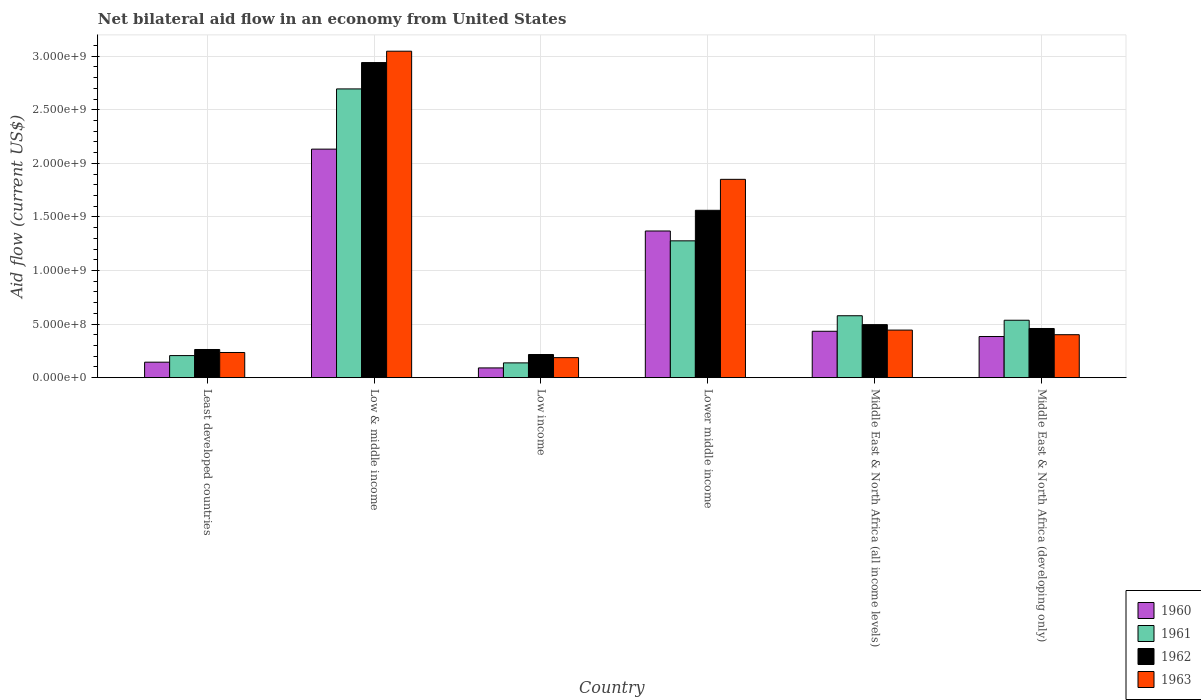How many bars are there on the 3rd tick from the left?
Your answer should be very brief. 4. How many bars are there on the 4th tick from the right?
Offer a very short reply. 4. What is the label of the 2nd group of bars from the left?
Your response must be concise. Low & middle income. In how many cases, is the number of bars for a given country not equal to the number of legend labels?
Offer a very short reply. 0. What is the net bilateral aid flow in 1960 in Lower middle income?
Your answer should be compact. 1.37e+09. Across all countries, what is the maximum net bilateral aid flow in 1962?
Your response must be concise. 2.94e+09. Across all countries, what is the minimum net bilateral aid flow in 1962?
Offer a very short reply. 2.16e+08. What is the total net bilateral aid flow in 1963 in the graph?
Offer a terse response. 6.16e+09. What is the difference between the net bilateral aid flow in 1963 in Least developed countries and that in Middle East & North Africa (developing only)?
Give a very brief answer. -1.66e+08. What is the difference between the net bilateral aid flow in 1962 in Lower middle income and the net bilateral aid flow in 1960 in Least developed countries?
Keep it short and to the point. 1.42e+09. What is the average net bilateral aid flow in 1960 per country?
Keep it short and to the point. 7.59e+08. What is the difference between the net bilateral aid flow of/in 1960 and net bilateral aid flow of/in 1963 in Middle East & North Africa (all income levels)?
Provide a short and direct response. -1.10e+07. What is the ratio of the net bilateral aid flow in 1961 in Lower middle income to that in Middle East & North Africa (all income levels)?
Ensure brevity in your answer.  2.21. Is the difference between the net bilateral aid flow in 1960 in Low income and Middle East & North Africa (developing only) greater than the difference between the net bilateral aid flow in 1963 in Low income and Middle East & North Africa (developing only)?
Provide a succinct answer. No. What is the difference between the highest and the second highest net bilateral aid flow in 1963?
Give a very brief answer. 2.60e+09. What is the difference between the highest and the lowest net bilateral aid flow in 1963?
Provide a succinct answer. 2.86e+09. In how many countries, is the net bilateral aid flow in 1961 greater than the average net bilateral aid flow in 1961 taken over all countries?
Make the answer very short. 2. Is the sum of the net bilateral aid flow in 1961 in Low & middle income and Low income greater than the maximum net bilateral aid flow in 1963 across all countries?
Give a very brief answer. No. Is it the case that in every country, the sum of the net bilateral aid flow in 1962 and net bilateral aid flow in 1960 is greater than the sum of net bilateral aid flow in 1963 and net bilateral aid flow in 1961?
Make the answer very short. No. What does the 2nd bar from the left in Middle East & North Africa (developing only) represents?
Ensure brevity in your answer.  1961. How many bars are there?
Your response must be concise. 24. Are the values on the major ticks of Y-axis written in scientific E-notation?
Keep it short and to the point. Yes. How many legend labels are there?
Provide a succinct answer. 4. How are the legend labels stacked?
Offer a very short reply. Vertical. What is the title of the graph?
Your answer should be very brief. Net bilateral aid flow in an economy from United States. What is the label or title of the X-axis?
Offer a very short reply. Country. What is the Aid flow (current US$) of 1960 in Least developed countries?
Ensure brevity in your answer.  1.45e+08. What is the Aid flow (current US$) in 1961 in Least developed countries?
Ensure brevity in your answer.  2.06e+08. What is the Aid flow (current US$) of 1962 in Least developed countries?
Provide a succinct answer. 2.63e+08. What is the Aid flow (current US$) in 1963 in Least developed countries?
Offer a terse response. 2.35e+08. What is the Aid flow (current US$) in 1960 in Low & middle income?
Make the answer very short. 2.13e+09. What is the Aid flow (current US$) of 1961 in Low & middle income?
Give a very brief answer. 2.70e+09. What is the Aid flow (current US$) in 1962 in Low & middle income?
Provide a succinct answer. 2.94e+09. What is the Aid flow (current US$) of 1963 in Low & middle income?
Provide a short and direct response. 3.05e+09. What is the Aid flow (current US$) in 1960 in Low income?
Make the answer very short. 9.10e+07. What is the Aid flow (current US$) in 1961 in Low income?
Give a very brief answer. 1.38e+08. What is the Aid flow (current US$) of 1962 in Low income?
Your answer should be very brief. 2.16e+08. What is the Aid flow (current US$) of 1963 in Low income?
Provide a succinct answer. 1.87e+08. What is the Aid flow (current US$) in 1960 in Lower middle income?
Provide a short and direct response. 1.37e+09. What is the Aid flow (current US$) of 1961 in Lower middle income?
Your answer should be compact. 1.28e+09. What is the Aid flow (current US$) of 1962 in Lower middle income?
Give a very brief answer. 1.56e+09. What is the Aid flow (current US$) in 1963 in Lower middle income?
Keep it short and to the point. 1.85e+09. What is the Aid flow (current US$) in 1960 in Middle East & North Africa (all income levels)?
Keep it short and to the point. 4.33e+08. What is the Aid flow (current US$) in 1961 in Middle East & North Africa (all income levels)?
Your response must be concise. 5.78e+08. What is the Aid flow (current US$) of 1962 in Middle East & North Africa (all income levels)?
Ensure brevity in your answer.  4.95e+08. What is the Aid flow (current US$) in 1963 in Middle East & North Africa (all income levels)?
Offer a very short reply. 4.44e+08. What is the Aid flow (current US$) of 1960 in Middle East & North Africa (developing only)?
Keep it short and to the point. 3.84e+08. What is the Aid flow (current US$) in 1961 in Middle East & North Africa (developing only)?
Provide a succinct answer. 5.36e+08. What is the Aid flow (current US$) in 1962 in Middle East & North Africa (developing only)?
Offer a terse response. 4.59e+08. What is the Aid flow (current US$) in 1963 in Middle East & North Africa (developing only)?
Provide a short and direct response. 4.01e+08. Across all countries, what is the maximum Aid flow (current US$) of 1960?
Keep it short and to the point. 2.13e+09. Across all countries, what is the maximum Aid flow (current US$) of 1961?
Give a very brief answer. 2.70e+09. Across all countries, what is the maximum Aid flow (current US$) in 1962?
Give a very brief answer. 2.94e+09. Across all countries, what is the maximum Aid flow (current US$) of 1963?
Make the answer very short. 3.05e+09. Across all countries, what is the minimum Aid flow (current US$) in 1960?
Give a very brief answer. 9.10e+07. Across all countries, what is the minimum Aid flow (current US$) of 1961?
Ensure brevity in your answer.  1.38e+08. Across all countries, what is the minimum Aid flow (current US$) of 1962?
Your answer should be very brief. 2.16e+08. Across all countries, what is the minimum Aid flow (current US$) of 1963?
Give a very brief answer. 1.87e+08. What is the total Aid flow (current US$) of 1960 in the graph?
Your response must be concise. 4.55e+09. What is the total Aid flow (current US$) in 1961 in the graph?
Offer a very short reply. 5.43e+09. What is the total Aid flow (current US$) of 1962 in the graph?
Provide a short and direct response. 5.94e+09. What is the total Aid flow (current US$) in 1963 in the graph?
Provide a short and direct response. 6.16e+09. What is the difference between the Aid flow (current US$) of 1960 in Least developed countries and that in Low & middle income?
Give a very brief answer. -1.99e+09. What is the difference between the Aid flow (current US$) of 1961 in Least developed countries and that in Low & middle income?
Keep it short and to the point. -2.49e+09. What is the difference between the Aid flow (current US$) of 1962 in Least developed countries and that in Low & middle income?
Offer a terse response. -2.68e+09. What is the difference between the Aid flow (current US$) in 1963 in Least developed countries and that in Low & middle income?
Your answer should be compact. -2.81e+09. What is the difference between the Aid flow (current US$) of 1960 in Least developed countries and that in Low income?
Offer a very short reply. 5.35e+07. What is the difference between the Aid flow (current US$) in 1961 in Least developed countries and that in Low income?
Provide a short and direct response. 6.80e+07. What is the difference between the Aid flow (current US$) of 1962 in Least developed countries and that in Low income?
Ensure brevity in your answer.  4.70e+07. What is the difference between the Aid flow (current US$) of 1963 in Least developed countries and that in Low income?
Provide a succinct answer. 4.80e+07. What is the difference between the Aid flow (current US$) in 1960 in Least developed countries and that in Lower middle income?
Your answer should be very brief. -1.22e+09. What is the difference between the Aid flow (current US$) of 1961 in Least developed countries and that in Lower middle income?
Make the answer very short. -1.07e+09. What is the difference between the Aid flow (current US$) of 1962 in Least developed countries and that in Lower middle income?
Give a very brief answer. -1.30e+09. What is the difference between the Aid flow (current US$) of 1963 in Least developed countries and that in Lower middle income?
Offer a very short reply. -1.62e+09. What is the difference between the Aid flow (current US$) in 1960 in Least developed countries and that in Middle East & North Africa (all income levels)?
Provide a short and direct response. -2.88e+08. What is the difference between the Aid flow (current US$) of 1961 in Least developed countries and that in Middle East & North Africa (all income levels)?
Ensure brevity in your answer.  -3.72e+08. What is the difference between the Aid flow (current US$) of 1962 in Least developed countries and that in Middle East & North Africa (all income levels)?
Your answer should be very brief. -2.32e+08. What is the difference between the Aid flow (current US$) in 1963 in Least developed countries and that in Middle East & North Africa (all income levels)?
Make the answer very short. -2.09e+08. What is the difference between the Aid flow (current US$) of 1960 in Least developed countries and that in Middle East & North Africa (developing only)?
Ensure brevity in your answer.  -2.39e+08. What is the difference between the Aid flow (current US$) of 1961 in Least developed countries and that in Middle East & North Africa (developing only)?
Give a very brief answer. -3.30e+08. What is the difference between the Aid flow (current US$) in 1962 in Least developed countries and that in Middle East & North Africa (developing only)?
Keep it short and to the point. -1.96e+08. What is the difference between the Aid flow (current US$) of 1963 in Least developed countries and that in Middle East & North Africa (developing only)?
Your response must be concise. -1.66e+08. What is the difference between the Aid flow (current US$) of 1960 in Low & middle income and that in Low income?
Offer a terse response. 2.04e+09. What is the difference between the Aid flow (current US$) in 1961 in Low & middle income and that in Low income?
Give a very brief answer. 2.56e+09. What is the difference between the Aid flow (current US$) in 1962 in Low & middle income and that in Low income?
Keep it short and to the point. 2.72e+09. What is the difference between the Aid flow (current US$) of 1963 in Low & middle income and that in Low income?
Provide a short and direct response. 2.86e+09. What is the difference between the Aid flow (current US$) of 1960 in Low & middle income and that in Lower middle income?
Provide a short and direct response. 7.64e+08. What is the difference between the Aid flow (current US$) of 1961 in Low & middle income and that in Lower middle income?
Keep it short and to the point. 1.42e+09. What is the difference between the Aid flow (current US$) of 1962 in Low & middle income and that in Lower middle income?
Give a very brief answer. 1.38e+09. What is the difference between the Aid flow (current US$) in 1963 in Low & middle income and that in Lower middle income?
Keep it short and to the point. 1.20e+09. What is the difference between the Aid flow (current US$) in 1960 in Low & middle income and that in Middle East & North Africa (all income levels)?
Provide a succinct answer. 1.70e+09. What is the difference between the Aid flow (current US$) of 1961 in Low & middle income and that in Middle East & North Africa (all income levels)?
Provide a succinct answer. 2.12e+09. What is the difference between the Aid flow (current US$) of 1962 in Low & middle income and that in Middle East & North Africa (all income levels)?
Ensure brevity in your answer.  2.45e+09. What is the difference between the Aid flow (current US$) of 1963 in Low & middle income and that in Middle East & North Africa (all income levels)?
Keep it short and to the point. 2.60e+09. What is the difference between the Aid flow (current US$) of 1960 in Low & middle income and that in Middle East & North Africa (developing only)?
Your answer should be compact. 1.75e+09. What is the difference between the Aid flow (current US$) of 1961 in Low & middle income and that in Middle East & North Africa (developing only)?
Your answer should be very brief. 2.16e+09. What is the difference between the Aid flow (current US$) of 1962 in Low & middle income and that in Middle East & North Africa (developing only)?
Your answer should be very brief. 2.48e+09. What is the difference between the Aid flow (current US$) of 1963 in Low & middle income and that in Middle East & North Africa (developing only)?
Ensure brevity in your answer.  2.65e+09. What is the difference between the Aid flow (current US$) in 1960 in Low income and that in Lower middle income?
Your response must be concise. -1.28e+09. What is the difference between the Aid flow (current US$) in 1961 in Low income and that in Lower middle income?
Ensure brevity in your answer.  -1.14e+09. What is the difference between the Aid flow (current US$) of 1962 in Low income and that in Lower middle income?
Make the answer very short. -1.35e+09. What is the difference between the Aid flow (current US$) of 1963 in Low income and that in Lower middle income?
Provide a succinct answer. -1.66e+09. What is the difference between the Aid flow (current US$) of 1960 in Low income and that in Middle East & North Africa (all income levels)?
Make the answer very short. -3.42e+08. What is the difference between the Aid flow (current US$) of 1961 in Low income and that in Middle East & North Africa (all income levels)?
Keep it short and to the point. -4.40e+08. What is the difference between the Aid flow (current US$) of 1962 in Low income and that in Middle East & North Africa (all income levels)?
Keep it short and to the point. -2.79e+08. What is the difference between the Aid flow (current US$) of 1963 in Low income and that in Middle East & North Africa (all income levels)?
Your response must be concise. -2.57e+08. What is the difference between the Aid flow (current US$) in 1960 in Low income and that in Middle East & North Africa (developing only)?
Offer a terse response. -2.93e+08. What is the difference between the Aid flow (current US$) in 1961 in Low income and that in Middle East & North Africa (developing only)?
Your response must be concise. -3.98e+08. What is the difference between the Aid flow (current US$) in 1962 in Low income and that in Middle East & North Africa (developing only)?
Ensure brevity in your answer.  -2.43e+08. What is the difference between the Aid flow (current US$) of 1963 in Low income and that in Middle East & North Africa (developing only)?
Give a very brief answer. -2.14e+08. What is the difference between the Aid flow (current US$) in 1960 in Lower middle income and that in Middle East & North Africa (all income levels)?
Keep it short and to the point. 9.36e+08. What is the difference between the Aid flow (current US$) of 1961 in Lower middle income and that in Middle East & North Africa (all income levels)?
Provide a short and direct response. 6.99e+08. What is the difference between the Aid flow (current US$) of 1962 in Lower middle income and that in Middle East & North Africa (all income levels)?
Ensure brevity in your answer.  1.07e+09. What is the difference between the Aid flow (current US$) of 1963 in Lower middle income and that in Middle East & North Africa (all income levels)?
Your answer should be very brief. 1.41e+09. What is the difference between the Aid flow (current US$) of 1960 in Lower middle income and that in Middle East & North Africa (developing only)?
Ensure brevity in your answer.  9.85e+08. What is the difference between the Aid flow (current US$) of 1961 in Lower middle income and that in Middle East & North Africa (developing only)?
Offer a terse response. 7.41e+08. What is the difference between the Aid flow (current US$) in 1962 in Lower middle income and that in Middle East & North Africa (developing only)?
Provide a succinct answer. 1.10e+09. What is the difference between the Aid flow (current US$) of 1963 in Lower middle income and that in Middle East & North Africa (developing only)?
Offer a very short reply. 1.45e+09. What is the difference between the Aid flow (current US$) in 1960 in Middle East & North Africa (all income levels) and that in Middle East & North Africa (developing only)?
Your answer should be compact. 4.90e+07. What is the difference between the Aid flow (current US$) in 1961 in Middle East & North Africa (all income levels) and that in Middle East & North Africa (developing only)?
Offer a very short reply. 4.20e+07. What is the difference between the Aid flow (current US$) of 1962 in Middle East & North Africa (all income levels) and that in Middle East & North Africa (developing only)?
Keep it short and to the point. 3.60e+07. What is the difference between the Aid flow (current US$) of 1963 in Middle East & North Africa (all income levels) and that in Middle East & North Africa (developing only)?
Your answer should be very brief. 4.30e+07. What is the difference between the Aid flow (current US$) in 1960 in Least developed countries and the Aid flow (current US$) in 1961 in Low & middle income?
Provide a short and direct response. -2.55e+09. What is the difference between the Aid flow (current US$) of 1960 in Least developed countries and the Aid flow (current US$) of 1962 in Low & middle income?
Provide a short and direct response. -2.80e+09. What is the difference between the Aid flow (current US$) in 1960 in Least developed countries and the Aid flow (current US$) in 1963 in Low & middle income?
Offer a very short reply. -2.90e+09. What is the difference between the Aid flow (current US$) in 1961 in Least developed countries and the Aid flow (current US$) in 1962 in Low & middle income?
Your answer should be compact. -2.74e+09. What is the difference between the Aid flow (current US$) of 1961 in Least developed countries and the Aid flow (current US$) of 1963 in Low & middle income?
Make the answer very short. -2.84e+09. What is the difference between the Aid flow (current US$) in 1962 in Least developed countries and the Aid flow (current US$) in 1963 in Low & middle income?
Offer a very short reply. -2.78e+09. What is the difference between the Aid flow (current US$) in 1960 in Least developed countries and the Aid flow (current US$) in 1961 in Low income?
Make the answer very short. 6.52e+06. What is the difference between the Aid flow (current US$) in 1960 in Least developed countries and the Aid flow (current US$) in 1962 in Low income?
Your response must be concise. -7.15e+07. What is the difference between the Aid flow (current US$) in 1960 in Least developed countries and the Aid flow (current US$) in 1963 in Low income?
Provide a short and direct response. -4.25e+07. What is the difference between the Aid flow (current US$) in 1961 in Least developed countries and the Aid flow (current US$) in 1962 in Low income?
Provide a succinct answer. -1.00e+07. What is the difference between the Aid flow (current US$) in 1961 in Least developed countries and the Aid flow (current US$) in 1963 in Low income?
Make the answer very short. 1.90e+07. What is the difference between the Aid flow (current US$) of 1962 in Least developed countries and the Aid flow (current US$) of 1963 in Low income?
Keep it short and to the point. 7.60e+07. What is the difference between the Aid flow (current US$) of 1960 in Least developed countries and the Aid flow (current US$) of 1961 in Lower middle income?
Offer a very short reply. -1.13e+09. What is the difference between the Aid flow (current US$) in 1960 in Least developed countries and the Aid flow (current US$) in 1962 in Lower middle income?
Give a very brief answer. -1.42e+09. What is the difference between the Aid flow (current US$) in 1960 in Least developed countries and the Aid flow (current US$) in 1963 in Lower middle income?
Provide a short and direct response. -1.71e+09. What is the difference between the Aid flow (current US$) of 1961 in Least developed countries and the Aid flow (current US$) of 1962 in Lower middle income?
Your answer should be compact. -1.36e+09. What is the difference between the Aid flow (current US$) of 1961 in Least developed countries and the Aid flow (current US$) of 1963 in Lower middle income?
Provide a succinct answer. -1.64e+09. What is the difference between the Aid flow (current US$) of 1962 in Least developed countries and the Aid flow (current US$) of 1963 in Lower middle income?
Offer a very short reply. -1.59e+09. What is the difference between the Aid flow (current US$) of 1960 in Least developed countries and the Aid flow (current US$) of 1961 in Middle East & North Africa (all income levels)?
Give a very brief answer. -4.33e+08. What is the difference between the Aid flow (current US$) in 1960 in Least developed countries and the Aid flow (current US$) in 1962 in Middle East & North Africa (all income levels)?
Offer a terse response. -3.50e+08. What is the difference between the Aid flow (current US$) of 1960 in Least developed countries and the Aid flow (current US$) of 1963 in Middle East & North Africa (all income levels)?
Give a very brief answer. -2.99e+08. What is the difference between the Aid flow (current US$) of 1961 in Least developed countries and the Aid flow (current US$) of 1962 in Middle East & North Africa (all income levels)?
Your answer should be compact. -2.89e+08. What is the difference between the Aid flow (current US$) in 1961 in Least developed countries and the Aid flow (current US$) in 1963 in Middle East & North Africa (all income levels)?
Provide a succinct answer. -2.38e+08. What is the difference between the Aid flow (current US$) of 1962 in Least developed countries and the Aid flow (current US$) of 1963 in Middle East & North Africa (all income levels)?
Offer a terse response. -1.81e+08. What is the difference between the Aid flow (current US$) of 1960 in Least developed countries and the Aid flow (current US$) of 1961 in Middle East & North Africa (developing only)?
Your response must be concise. -3.91e+08. What is the difference between the Aid flow (current US$) in 1960 in Least developed countries and the Aid flow (current US$) in 1962 in Middle East & North Africa (developing only)?
Your answer should be compact. -3.14e+08. What is the difference between the Aid flow (current US$) in 1960 in Least developed countries and the Aid flow (current US$) in 1963 in Middle East & North Africa (developing only)?
Offer a very short reply. -2.56e+08. What is the difference between the Aid flow (current US$) in 1961 in Least developed countries and the Aid flow (current US$) in 1962 in Middle East & North Africa (developing only)?
Your answer should be very brief. -2.53e+08. What is the difference between the Aid flow (current US$) of 1961 in Least developed countries and the Aid flow (current US$) of 1963 in Middle East & North Africa (developing only)?
Provide a succinct answer. -1.95e+08. What is the difference between the Aid flow (current US$) in 1962 in Least developed countries and the Aid flow (current US$) in 1963 in Middle East & North Africa (developing only)?
Your answer should be very brief. -1.38e+08. What is the difference between the Aid flow (current US$) of 1960 in Low & middle income and the Aid flow (current US$) of 1961 in Low income?
Provide a succinct answer. 2.00e+09. What is the difference between the Aid flow (current US$) of 1960 in Low & middle income and the Aid flow (current US$) of 1962 in Low income?
Your response must be concise. 1.92e+09. What is the difference between the Aid flow (current US$) of 1960 in Low & middle income and the Aid flow (current US$) of 1963 in Low income?
Give a very brief answer. 1.95e+09. What is the difference between the Aid flow (current US$) in 1961 in Low & middle income and the Aid flow (current US$) in 1962 in Low income?
Provide a short and direct response. 2.48e+09. What is the difference between the Aid flow (current US$) in 1961 in Low & middle income and the Aid flow (current US$) in 1963 in Low income?
Provide a succinct answer. 2.51e+09. What is the difference between the Aid flow (current US$) in 1962 in Low & middle income and the Aid flow (current US$) in 1963 in Low income?
Your response must be concise. 2.75e+09. What is the difference between the Aid flow (current US$) of 1960 in Low & middle income and the Aid flow (current US$) of 1961 in Lower middle income?
Provide a short and direct response. 8.56e+08. What is the difference between the Aid flow (current US$) in 1960 in Low & middle income and the Aid flow (current US$) in 1962 in Lower middle income?
Your answer should be very brief. 5.71e+08. What is the difference between the Aid flow (current US$) of 1960 in Low & middle income and the Aid flow (current US$) of 1963 in Lower middle income?
Offer a terse response. 2.82e+08. What is the difference between the Aid flow (current US$) in 1961 in Low & middle income and the Aid flow (current US$) in 1962 in Lower middle income?
Your answer should be very brief. 1.13e+09. What is the difference between the Aid flow (current US$) of 1961 in Low & middle income and the Aid flow (current US$) of 1963 in Lower middle income?
Your answer should be very brief. 8.44e+08. What is the difference between the Aid flow (current US$) of 1962 in Low & middle income and the Aid flow (current US$) of 1963 in Lower middle income?
Your answer should be very brief. 1.09e+09. What is the difference between the Aid flow (current US$) of 1960 in Low & middle income and the Aid flow (current US$) of 1961 in Middle East & North Africa (all income levels)?
Make the answer very short. 1.56e+09. What is the difference between the Aid flow (current US$) of 1960 in Low & middle income and the Aid flow (current US$) of 1962 in Middle East & North Africa (all income levels)?
Provide a succinct answer. 1.64e+09. What is the difference between the Aid flow (current US$) in 1960 in Low & middle income and the Aid flow (current US$) in 1963 in Middle East & North Africa (all income levels)?
Offer a very short reply. 1.69e+09. What is the difference between the Aid flow (current US$) in 1961 in Low & middle income and the Aid flow (current US$) in 1962 in Middle East & North Africa (all income levels)?
Offer a very short reply. 2.20e+09. What is the difference between the Aid flow (current US$) in 1961 in Low & middle income and the Aid flow (current US$) in 1963 in Middle East & North Africa (all income levels)?
Give a very brief answer. 2.25e+09. What is the difference between the Aid flow (current US$) in 1962 in Low & middle income and the Aid flow (current US$) in 1963 in Middle East & North Africa (all income levels)?
Your response must be concise. 2.50e+09. What is the difference between the Aid flow (current US$) in 1960 in Low & middle income and the Aid flow (current US$) in 1961 in Middle East & North Africa (developing only)?
Your answer should be compact. 1.60e+09. What is the difference between the Aid flow (current US$) in 1960 in Low & middle income and the Aid flow (current US$) in 1962 in Middle East & North Africa (developing only)?
Keep it short and to the point. 1.67e+09. What is the difference between the Aid flow (current US$) in 1960 in Low & middle income and the Aid flow (current US$) in 1963 in Middle East & North Africa (developing only)?
Offer a terse response. 1.73e+09. What is the difference between the Aid flow (current US$) in 1961 in Low & middle income and the Aid flow (current US$) in 1962 in Middle East & North Africa (developing only)?
Provide a succinct answer. 2.24e+09. What is the difference between the Aid flow (current US$) of 1961 in Low & middle income and the Aid flow (current US$) of 1963 in Middle East & North Africa (developing only)?
Keep it short and to the point. 2.29e+09. What is the difference between the Aid flow (current US$) in 1962 in Low & middle income and the Aid flow (current US$) in 1963 in Middle East & North Africa (developing only)?
Offer a terse response. 2.54e+09. What is the difference between the Aid flow (current US$) in 1960 in Low income and the Aid flow (current US$) in 1961 in Lower middle income?
Keep it short and to the point. -1.19e+09. What is the difference between the Aid flow (current US$) in 1960 in Low income and the Aid flow (current US$) in 1962 in Lower middle income?
Ensure brevity in your answer.  -1.47e+09. What is the difference between the Aid flow (current US$) of 1960 in Low income and the Aid flow (current US$) of 1963 in Lower middle income?
Give a very brief answer. -1.76e+09. What is the difference between the Aid flow (current US$) of 1961 in Low income and the Aid flow (current US$) of 1962 in Lower middle income?
Your answer should be very brief. -1.42e+09. What is the difference between the Aid flow (current US$) of 1961 in Low income and the Aid flow (current US$) of 1963 in Lower middle income?
Provide a succinct answer. -1.71e+09. What is the difference between the Aid flow (current US$) of 1962 in Low income and the Aid flow (current US$) of 1963 in Lower middle income?
Your response must be concise. -1.64e+09. What is the difference between the Aid flow (current US$) in 1960 in Low income and the Aid flow (current US$) in 1961 in Middle East & North Africa (all income levels)?
Your answer should be very brief. -4.87e+08. What is the difference between the Aid flow (current US$) of 1960 in Low income and the Aid flow (current US$) of 1962 in Middle East & North Africa (all income levels)?
Your answer should be very brief. -4.04e+08. What is the difference between the Aid flow (current US$) of 1960 in Low income and the Aid flow (current US$) of 1963 in Middle East & North Africa (all income levels)?
Make the answer very short. -3.53e+08. What is the difference between the Aid flow (current US$) in 1961 in Low income and the Aid flow (current US$) in 1962 in Middle East & North Africa (all income levels)?
Your answer should be very brief. -3.57e+08. What is the difference between the Aid flow (current US$) in 1961 in Low income and the Aid flow (current US$) in 1963 in Middle East & North Africa (all income levels)?
Make the answer very short. -3.06e+08. What is the difference between the Aid flow (current US$) of 1962 in Low income and the Aid flow (current US$) of 1963 in Middle East & North Africa (all income levels)?
Your response must be concise. -2.28e+08. What is the difference between the Aid flow (current US$) in 1960 in Low income and the Aid flow (current US$) in 1961 in Middle East & North Africa (developing only)?
Keep it short and to the point. -4.45e+08. What is the difference between the Aid flow (current US$) of 1960 in Low income and the Aid flow (current US$) of 1962 in Middle East & North Africa (developing only)?
Offer a very short reply. -3.68e+08. What is the difference between the Aid flow (current US$) of 1960 in Low income and the Aid flow (current US$) of 1963 in Middle East & North Africa (developing only)?
Make the answer very short. -3.10e+08. What is the difference between the Aid flow (current US$) in 1961 in Low income and the Aid flow (current US$) in 1962 in Middle East & North Africa (developing only)?
Provide a succinct answer. -3.21e+08. What is the difference between the Aid flow (current US$) of 1961 in Low income and the Aid flow (current US$) of 1963 in Middle East & North Africa (developing only)?
Make the answer very short. -2.63e+08. What is the difference between the Aid flow (current US$) in 1962 in Low income and the Aid flow (current US$) in 1963 in Middle East & North Africa (developing only)?
Your answer should be compact. -1.85e+08. What is the difference between the Aid flow (current US$) of 1960 in Lower middle income and the Aid flow (current US$) of 1961 in Middle East & North Africa (all income levels)?
Your answer should be compact. 7.91e+08. What is the difference between the Aid flow (current US$) of 1960 in Lower middle income and the Aid flow (current US$) of 1962 in Middle East & North Africa (all income levels)?
Make the answer very short. 8.74e+08. What is the difference between the Aid flow (current US$) in 1960 in Lower middle income and the Aid flow (current US$) in 1963 in Middle East & North Africa (all income levels)?
Ensure brevity in your answer.  9.25e+08. What is the difference between the Aid flow (current US$) in 1961 in Lower middle income and the Aid flow (current US$) in 1962 in Middle East & North Africa (all income levels)?
Offer a very short reply. 7.82e+08. What is the difference between the Aid flow (current US$) in 1961 in Lower middle income and the Aid flow (current US$) in 1963 in Middle East & North Africa (all income levels)?
Your response must be concise. 8.33e+08. What is the difference between the Aid flow (current US$) in 1962 in Lower middle income and the Aid flow (current US$) in 1963 in Middle East & North Africa (all income levels)?
Make the answer very short. 1.12e+09. What is the difference between the Aid flow (current US$) in 1960 in Lower middle income and the Aid flow (current US$) in 1961 in Middle East & North Africa (developing only)?
Your response must be concise. 8.33e+08. What is the difference between the Aid flow (current US$) in 1960 in Lower middle income and the Aid flow (current US$) in 1962 in Middle East & North Africa (developing only)?
Provide a succinct answer. 9.10e+08. What is the difference between the Aid flow (current US$) in 1960 in Lower middle income and the Aid flow (current US$) in 1963 in Middle East & North Africa (developing only)?
Keep it short and to the point. 9.68e+08. What is the difference between the Aid flow (current US$) of 1961 in Lower middle income and the Aid flow (current US$) of 1962 in Middle East & North Africa (developing only)?
Keep it short and to the point. 8.18e+08. What is the difference between the Aid flow (current US$) of 1961 in Lower middle income and the Aid flow (current US$) of 1963 in Middle East & North Africa (developing only)?
Provide a short and direct response. 8.76e+08. What is the difference between the Aid flow (current US$) in 1962 in Lower middle income and the Aid flow (current US$) in 1963 in Middle East & North Africa (developing only)?
Provide a short and direct response. 1.16e+09. What is the difference between the Aid flow (current US$) of 1960 in Middle East & North Africa (all income levels) and the Aid flow (current US$) of 1961 in Middle East & North Africa (developing only)?
Your answer should be compact. -1.03e+08. What is the difference between the Aid flow (current US$) in 1960 in Middle East & North Africa (all income levels) and the Aid flow (current US$) in 1962 in Middle East & North Africa (developing only)?
Your response must be concise. -2.60e+07. What is the difference between the Aid flow (current US$) of 1960 in Middle East & North Africa (all income levels) and the Aid flow (current US$) of 1963 in Middle East & North Africa (developing only)?
Ensure brevity in your answer.  3.20e+07. What is the difference between the Aid flow (current US$) in 1961 in Middle East & North Africa (all income levels) and the Aid flow (current US$) in 1962 in Middle East & North Africa (developing only)?
Your answer should be very brief. 1.19e+08. What is the difference between the Aid flow (current US$) in 1961 in Middle East & North Africa (all income levels) and the Aid flow (current US$) in 1963 in Middle East & North Africa (developing only)?
Provide a succinct answer. 1.77e+08. What is the difference between the Aid flow (current US$) of 1962 in Middle East & North Africa (all income levels) and the Aid flow (current US$) of 1963 in Middle East & North Africa (developing only)?
Make the answer very short. 9.40e+07. What is the average Aid flow (current US$) in 1960 per country?
Offer a very short reply. 7.59e+08. What is the average Aid flow (current US$) of 1961 per country?
Offer a very short reply. 9.05e+08. What is the average Aid flow (current US$) in 1962 per country?
Provide a short and direct response. 9.89e+08. What is the average Aid flow (current US$) in 1963 per country?
Your answer should be compact. 1.03e+09. What is the difference between the Aid flow (current US$) in 1960 and Aid flow (current US$) in 1961 in Least developed countries?
Ensure brevity in your answer.  -6.15e+07. What is the difference between the Aid flow (current US$) of 1960 and Aid flow (current US$) of 1962 in Least developed countries?
Offer a very short reply. -1.18e+08. What is the difference between the Aid flow (current US$) in 1960 and Aid flow (current US$) in 1963 in Least developed countries?
Offer a very short reply. -9.05e+07. What is the difference between the Aid flow (current US$) in 1961 and Aid flow (current US$) in 1962 in Least developed countries?
Ensure brevity in your answer.  -5.70e+07. What is the difference between the Aid flow (current US$) in 1961 and Aid flow (current US$) in 1963 in Least developed countries?
Offer a terse response. -2.90e+07. What is the difference between the Aid flow (current US$) of 1962 and Aid flow (current US$) of 1963 in Least developed countries?
Your answer should be compact. 2.80e+07. What is the difference between the Aid flow (current US$) of 1960 and Aid flow (current US$) of 1961 in Low & middle income?
Your answer should be very brief. -5.62e+08. What is the difference between the Aid flow (current US$) of 1960 and Aid flow (current US$) of 1962 in Low & middle income?
Keep it short and to the point. -8.08e+08. What is the difference between the Aid flow (current US$) of 1960 and Aid flow (current US$) of 1963 in Low & middle income?
Provide a short and direct response. -9.14e+08. What is the difference between the Aid flow (current US$) in 1961 and Aid flow (current US$) in 1962 in Low & middle income?
Make the answer very short. -2.46e+08. What is the difference between the Aid flow (current US$) in 1961 and Aid flow (current US$) in 1963 in Low & middle income?
Your answer should be very brief. -3.52e+08. What is the difference between the Aid flow (current US$) in 1962 and Aid flow (current US$) in 1963 in Low & middle income?
Your answer should be compact. -1.06e+08. What is the difference between the Aid flow (current US$) in 1960 and Aid flow (current US$) in 1961 in Low income?
Offer a terse response. -4.70e+07. What is the difference between the Aid flow (current US$) of 1960 and Aid flow (current US$) of 1962 in Low income?
Offer a very short reply. -1.25e+08. What is the difference between the Aid flow (current US$) of 1960 and Aid flow (current US$) of 1963 in Low income?
Ensure brevity in your answer.  -9.60e+07. What is the difference between the Aid flow (current US$) of 1961 and Aid flow (current US$) of 1962 in Low income?
Your answer should be compact. -7.80e+07. What is the difference between the Aid flow (current US$) in 1961 and Aid flow (current US$) in 1963 in Low income?
Provide a succinct answer. -4.90e+07. What is the difference between the Aid flow (current US$) of 1962 and Aid flow (current US$) of 1963 in Low income?
Provide a succinct answer. 2.90e+07. What is the difference between the Aid flow (current US$) of 1960 and Aid flow (current US$) of 1961 in Lower middle income?
Provide a short and direct response. 9.20e+07. What is the difference between the Aid flow (current US$) in 1960 and Aid flow (current US$) in 1962 in Lower middle income?
Give a very brief answer. -1.93e+08. What is the difference between the Aid flow (current US$) in 1960 and Aid flow (current US$) in 1963 in Lower middle income?
Offer a terse response. -4.82e+08. What is the difference between the Aid flow (current US$) of 1961 and Aid flow (current US$) of 1962 in Lower middle income?
Keep it short and to the point. -2.85e+08. What is the difference between the Aid flow (current US$) of 1961 and Aid flow (current US$) of 1963 in Lower middle income?
Your answer should be compact. -5.74e+08. What is the difference between the Aid flow (current US$) in 1962 and Aid flow (current US$) in 1963 in Lower middle income?
Your answer should be very brief. -2.89e+08. What is the difference between the Aid flow (current US$) in 1960 and Aid flow (current US$) in 1961 in Middle East & North Africa (all income levels)?
Provide a short and direct response. -1.45e+08. What is the difference between the Aid flow (current US$) in 1960 and Aid flow (current US$) in 1962 in Middle East & North Africa (all income levels)?
Your answer should be very brief. -6.20e+07. What is the difference between the Aid flow (current US$) in 1960 and Aid flow (current US$) in 1963 in Middle East & North Africa (all income levels)?
Your answer should be compact. -1.10e+07. What is the difference between the Aid flow (current US$) in 1961 and Aid flow (current US$) in 1962 in Middle East & North Africa (all income levels)?
Your answer should be very brief. 8.30e+07. What is the difference between the Aid flow (current US$) in 1961 and Aid flow (current US$) in 1963 in Middle East & North Africa (all income levels)?
Your answer should be compact. 1.34e+08. What is the difference between the Aid flow (current US$) of 1962 and Aid flow (current US$) of 1963 in Middle East & North Africa (all income levels)?
Give a very brief answer. 5.10e+07. What is the difference between the Aid flow (current US$) in 1960 and Aid flow (current US$) in 1961 in Middle East & North Africa (developing only)?
Your answer should be compact. -1.52e+08. What is the difference between the Aid flow (current US$) of 1960 and Aid flow (current US$) of 1962 in Middle East & North Africa (developing only)?
Keep it short and to the point. -7.50e+07. What is the difference between the Aid flow (current US$) in 1960 and Aid flow (current US$) in 1963 in Middle East & North Africa (developing only)?
Offer a terse response. -1.70e+07. What is the difference between the Aid flow (current US$) of 1961 and Aid flow (current US$) of 1962 in Middle East & North Africa (developing only)?
Keep it short and to the point. 7.70e+07. What is the difference between the Aid flow (current US$) of 1961 and Aid flow (current US$) of 1963 in Middle East & North Africa (developing only)?
Offer a very short reply. 1.35e+08. What is the difference between the Aid flow (current US$) of 1962 and Aid flow (current US$) of 1963 in Middle East & North Africa (developing only)?
Your response must be concise. 5.80e+07. What is the ratio of the Aid flow (current US$) in 1960 in Least developed countries to that in Low & middle income?
Offer a very short reply. 0.07. What is the ratio of the Aid flow (current US$) of 1961 in Least developed countries to that in Low & middle income?
Ensure brevity in your answer.  0.08. What is the ratio of the Aid flow (current US$) in 1962 in Least developed countries to that in Low & middle income?
Provide a short and direct response. 0.09. What is the ratio of the Aid flow (current US$) in 1963 in Least developed countries to that in Low & middle income?
Provide a succinct answer. 0.08. What is the ratio of the Aid flow (current US$) in 1960 in Least developed countries to that in Low income?
Your answer should be compact. 1.59. What is the ratio of the Aid flow (current US$) of 1961 in Least developed countries to that in Low income?
Ensure brevity in your answer.  1.49. What is the ratio of the Aid flow (current US$) in 1962 in Least developed countries to that in Low income?
Your answer should be very brief. 1.22. What is the ratio of the Aid flow (current US$) in 1963 in Least developed countries to that in Low income?
Your response must be concise. 1.26. What is the ratio of the Aid flow (current US$) of 1960 in Least developed countries to that in Lower middle income?
Offer a terse response. 0.11. What is the ratio of the Aid flow (current US$) in 1961 in Least developed countries to that in Lower middle income?
Offer a terse response. 0.16. What is the ratio of the Aid flow (current US$) in 1962 in Least developed countries to that in Lower middle income?
Your answer should be very brief. 0.17. What is the ratio of the Aid flow (current US$) in 1963 in Least developed countries to that in Lower middle income?
Provide a short and direct response. 0.13. What is the ratio of the Aid flow (current US$) of 1960 in Least developed countries to that in Middle East & North Africa (all income levels)?
Provide a short and direct response. 0.33. What is the ratio of the Aid flow (current US$) of 1961 in Least developed countries to that in Middle East & North Africa (all income levels)?
Your answer should be compact. 0.36. What is the ratio of the Aid flow (current US$) in 1962 in Least developed countries to that in Middle East & North Africa (all income levels)?
Your response must be concise. 0.53. What is the ratio of the Aid flow (current US$) in 1963 in Least developed countries to that in Middle East & North Africa (all income levels)?
Ensure brevity in your answer.  0.53. What is the ratio of the Aid flow (current US$) of 1960 in Least developed countries to that in Middle East & North Africa (developing only)?
Make the answer very short. 0.38. What is the ratio of the Aid flow (current US$) in 1961 in Least developed countries to that in Middle East & North Africa (developing only)?
Offer a terse response. 0.38. What is the ratio of the Aid flow (current US$) in 1962 in Least developed countries to that in Middle East & North Africa (developing only)?
Offer a very short reply. 0.57. What is the ratio of the Aid flow (current US$) of 1963 in Least developed countries to that in Middle East & North Africa (developing only)?
Offer a terse response. 0.59. What is the ratio of the Aid flow (current US$) of 1960 in Low & middle income to that in Low income?
Your answer should be very brief. 23.44. What is the ratio of the Aid flow (current US$) in 1961 in Low & middle income to that in Low income?
Keep it short and to the point. 19.53. What is the ratio of the Aid flow (current US$) in 1962 in Low & middle income to that in Low income?
Your response must be concise. 13.62. What is the ratio of the Aid flow (current US$) of 1963 in Low & middle income to that in Low income?
Provide a succinct answer. 16.29. What is the ratio of the Aid flow (current US$) in 1960 in Low & middle income to that in Lower middle income?
Give a very brief answer. 1.56. What is the ratio of the Aid flow (current US$) in 1961 in Low & middle income to that in Lower middle income?
Your answer should be very brief. 2.11. What is the ratio of the Aid flow (current US$) of 1962 in Low & middle income to that in Lower middle income?
Your answer should be very brief. 1.88. What is the ratio of the Aid flow (current US$) in 1963 in Low & middle income to that in Lower middle income?
Provide a succinct answer. 1.65. What is the ratio of the Aid flow (current US$) of 1960 in Low & middle income to that in Middle East & North Africa (all income levels)?
Make the answer very short. 4.93. What is the ratio of the Aid flow (current US$) in 1961 in Low & middle income to that in Middle East & North Africa (all income levels)?
Keep it short and to the point. 4.66. What is the ratio of the Aid flow (current US$) of 1962 in Low & middle income to that in Middle East & North Africa (all income levels)?
Give a very brief answer. 5.94. What is the ratio of the Aid flow (current US$) in 1963 in Low & middle income to that in Middle East & North Africa (all income levels)?
Your response must be concise. 6.86. What is the ratio of the Aid flow (current US$) of 1960 in Low & middle income to that in Middle East & North Africa (developing only)?
Offer a terse response. 5.55. What is the ratio of the Aid flow (current US$) in 1961 in Low & middle income to that in Middle East & North Africa (developing only)?
Offer a very short reply. 5.03. What is the ratio of the Aid flow (current US$) of 1962 in Low & middle income to that in Middle East & North Africa (developing only)?
Offer a very short reply. 6.41. What is the ratio of the Aid flow (current US$) of 1963 in Low & middle income to that in Middle East & North Africa (developing only)?
Your response must be concise. 7.6. What is the ratio of the Aid flow (current US$) in 1960 in Low income to that in Lower middle income?
Keep it short and to the point. 0.07. What is the ratio of the Aid flow (current US$) of 1961 in Low income to that in Lower middle income?
Your response must be concise. 0.11. What is the ratio of the Aid flow (current US$) of 1962 in Low income to that in Lower middle income?
Keep it short and to the point. 0.14. What is the ratio of the Aid flow (current US$) in 1963 in Low income to that in Lower middle income?
Provide a succinct answer. 0.1. What is the ratio of the Aid flow (current US$) of 1960 in Low income to that in Middle East & North Africa (all income levels)?
Make the answer very short. 0.21. What is the ratio of the Aid flow (current US$) in 1961 in Low income to that in Middle East & North Africa (all income levels)?
Provide a short and direct response. 0.24. What is the ratio of the Aid flow (current US$) of 1962 in Low income to that in Middle East & North Africa (all income levels)?
Give a very brief answer. 0.44. What is the ratio of the Aid flow (current US$) of 1963 in Low income to that in Middle East & North Africa (all income levels)?
Offer a terse response. 0.42. What is the ratio of the Aid flow (current US$) of 1960 in Low income to that in Middle East & North Africa (developing only)?
Offer a terse response. 0.24. What is the ratio of the Aid flow (current US$) of 1961 in Low income to that in Middle East & North Africa (developing only)?
Offer a terse response. 0.26. What is the ratio of the Aid flow (current US$) of 1962 in Low income to that in Middle East & North Africa (developing only)?
Your answer should be very brief. 0.47. What is the ratio of the Aid flow (current US$) in 1963 in Low income to that in Middle East & North Africa (developing only)?
Ensure brevity in your answer.  0.47. What is the ratio of the Aid flow (current US$) of 1960 in Lower middle income to that in Middle East & North Africa (all income levels)?
Your answer should be compact. 3.16. What is the ratio of the Aid flow (current US$) in 1961 in Lower middle income to that in Middle East & North Africa (all income levels)?
Provide a succinct answer. 2.21. What is the ratio of the Aid flow (current US$) in 1962 in Lower middle income to that in Middle East & North Africa (all income levels)?
Your answer should be very brief. 3.16. What is the ratio of the Aid flow (current US$) of 1963 in Lower middle income to that in Middle East & North Africa (all income levels)?
Keep it short and to the point. 4.17. What is the ratio of the Aid flow (current US$) of 1960 in Lower middle income to that in Middle East & North Africa (developing only)?
Your response must be concise. 3.57. What is the ratio of the Aid flow (current US$) in 1961 in Lower middle income to that in Middle East & North Africa (developing only)?
Offer a terse response. 2.38. What is the ratio of the Aid flow (current US$) of 1962 in Lower middle income to that in Middle East & North Africa (developing only)?
Offer a very short reply. 3.4. What is the ratio of the Aid flow (current US$) in 1963 in Lower middle income to that in Middle East & North Africa (developing only)?
Give a very brief answer. 4.62. What is the ratio of the Aid flow (current US$) of 1960 in Middle East & North Africa (all income levels) to that in Middle East & North Africa (developing only)?
Offer a very short reply. 1.13. What is the ratio of the Aid flow (current US$) in 1961 in Middle East & North Africa (all income levels) to that in Middle East & North Africa (developing only)?
Offer a very short reply. 1.08. What is the ratio of the Aid flow (current US$) of 1962 in Middle East & North Africa (all income levels) to that in Middle East & North Africa (developing only)?
Make the answer very short. 1.08. What is the ratio of the Aid flow (current US$) in 1963 in Middle East & North Africa (all income levels) to that in Middle East & North Africa (developing only)?
Ensure brevity in your answer.  1.11. What is the difference between the highest and the second highest Aid flow (current US$) in 1960?
Make the answer very short. 7.64e+08. What is the difference between the highest and the second highest Aid flow (current US$) of 1961?
Provide a short and direct response. 1.42e+09. What is the difference between the highest and the second highest Aid flow (current US$) of 1962?
Make the answer very short. 1.38e+09. What is the difference between the highest and the second highest Aid flow (current US$) in 1963?
Provide a short and direct response. 1.20e+09. What is the difference between the highest and the lowest Aid flow (current US$) in 1960?
Your answer should be very brief. 2.04e+09. What is the difference between the highest and the lowest Aid flow (current US$) in 1961?
Offer a terse response. 2.56e+09. What is the difference between the highest and the lowest Aid flow (current US$) of 1962?
Offer a terse response. 2.72e+09. What is the difference between the highest and the lowest Aid flow (current US$) of 1963?
Provide a succinct answer. 2.86e+09. 